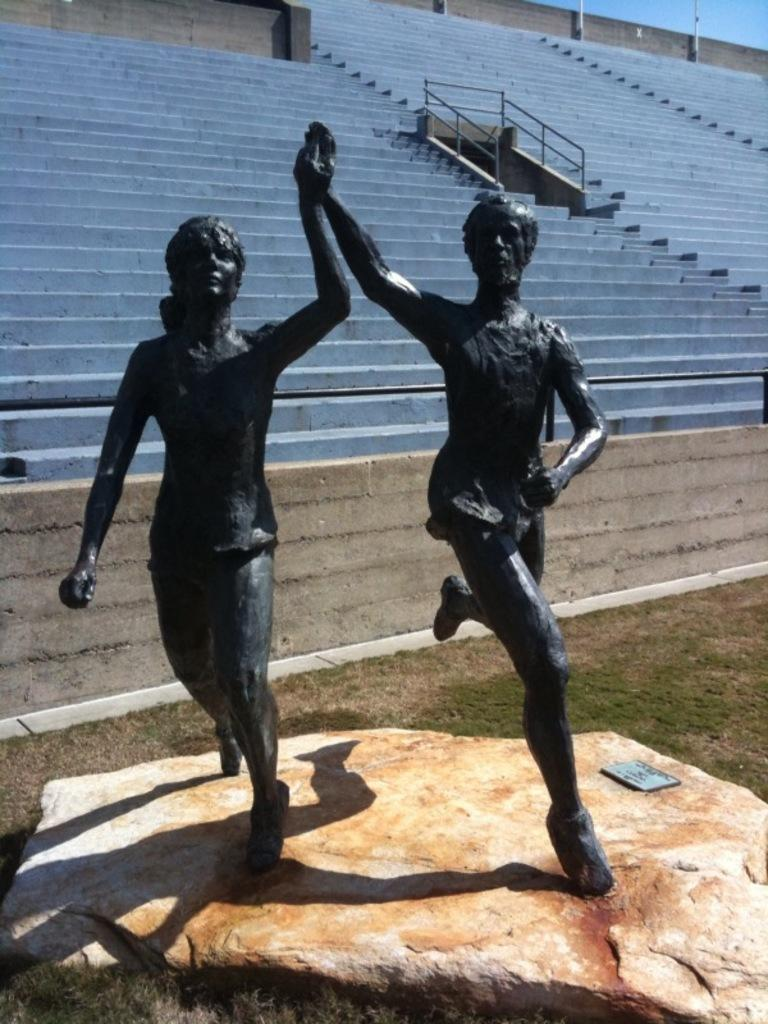What type of architectural feature is present in the image? There are steps in the image. What can be seen in the middle of the image? There are statues in the middle of the image. What is located at the bottom of the image? There is a rock at the bottom of the image. What type of story is being told by the statues in the image? There is no story being told by the statues in the image; they are simply statues. What kind of apparatus is used to climb the rock in the image? There is no apparatus present in the image, and the rock is located at the bottom. 